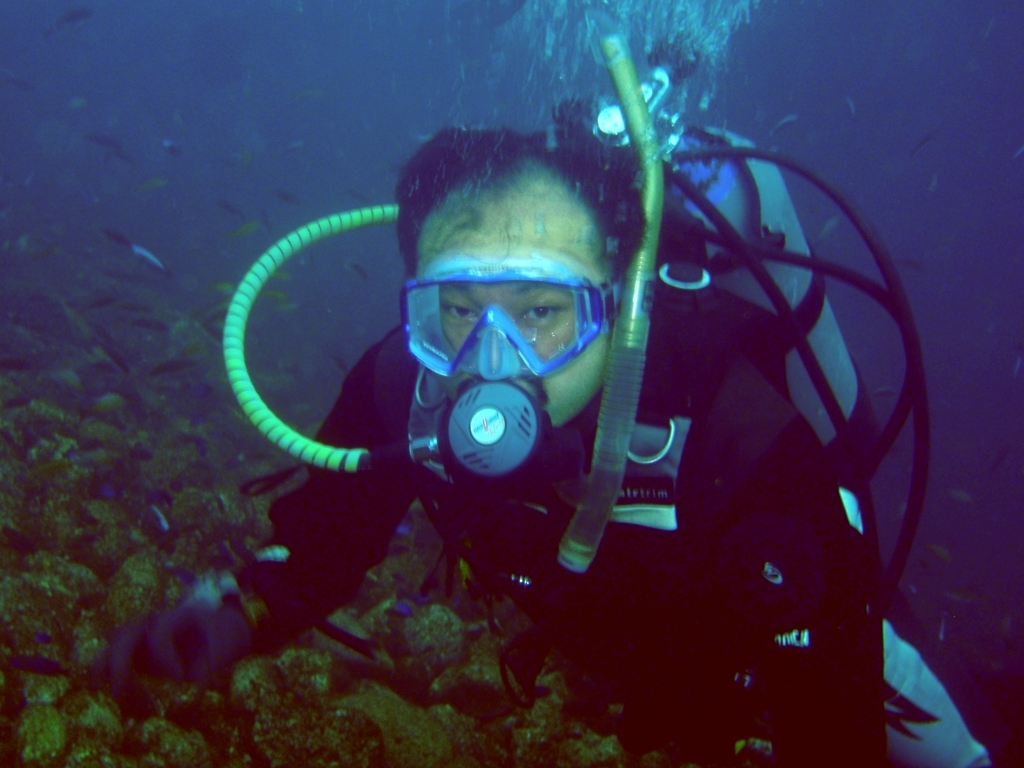Which color tone does this photo primarily lean towards?
A. Yellow
B. Blue
C. Red
Answer with the option's letter from the given choices directly.
 B. 